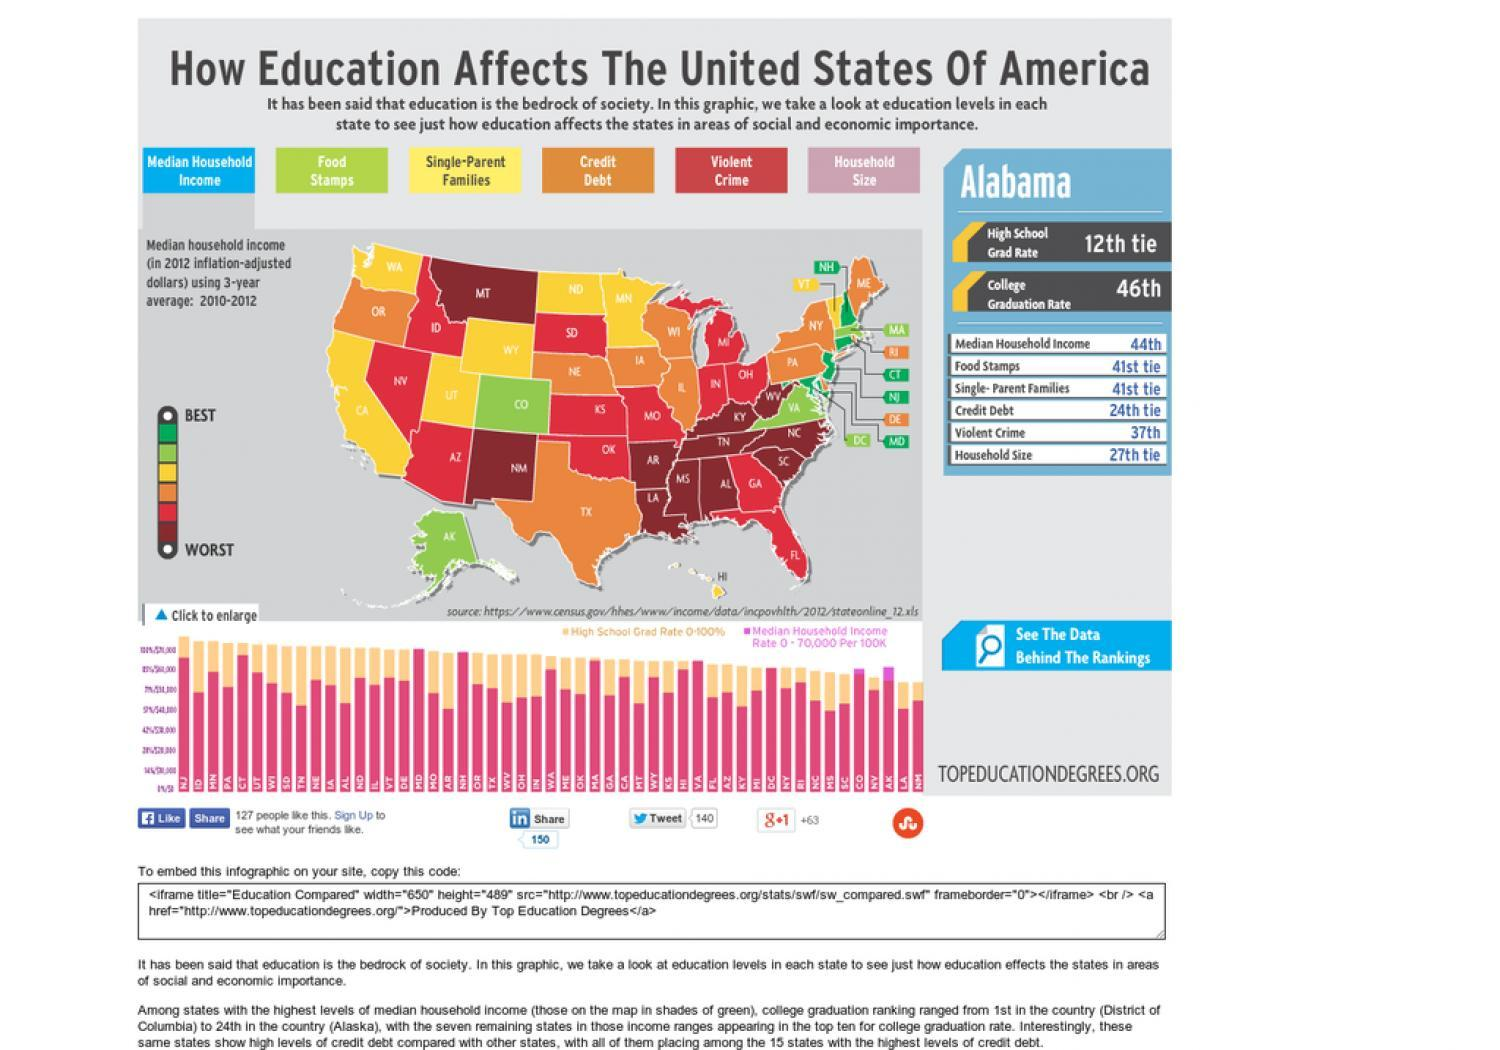As per the color code, in which range does median household income for the state of NJ fall?
Answer the question with a short phrase. Best How many states are shown in yellow? 8 